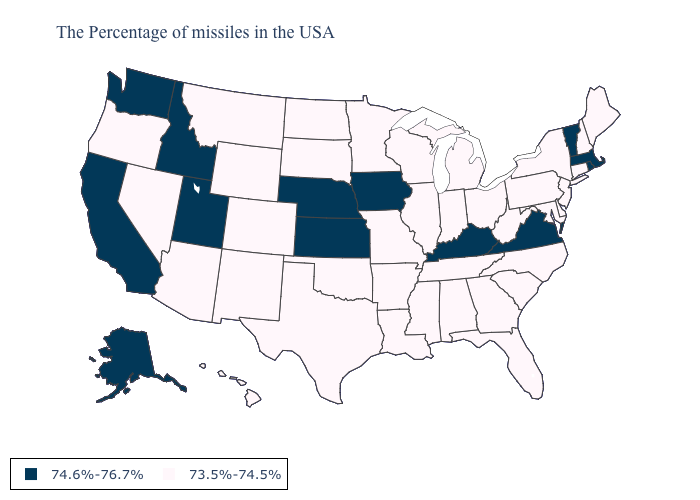Name the states that have a value in the range 74.6%-76.7%?
Be succinct. Massachusetts, Rhode Island, Vermont, Virginia, Kentucky, Iowa, Kansas, Nebraska, Utah, Idaho, California, Washington, Alaska. Name the states that have a value in the range 73.5%-74.5%?
Quick response, please. Maine, New Hampshire, Connecticut, New York, New Jersey, Delaware, Maryland, Pennsylvania, North Carolina, South Carolina, West Virginia, Ohio, Florida, Georgia, Michigan, Indiana, Alabama, Tennessee, Wisconsin, Illinois, Mississippi, Louisiana, Missouri, Arkansas, Minnesota, Oklahoma, Texas, South Dakota, North Dakota, Wyoming, Colorado, New Mexico, Montana, Arizona, Nevada, Oregon, Hawaii. What is the highest value in states that border Connecticut?
Short answer required. 74.6%-76.7%. Does the map have missing data?
Keep it brief. No. Does Hawaii have a higher value than West Virginia?
Answer briefly. No. Which states have the lowest value in the MidWest?
Answer briefly. Ohio, Michigan, Indiana, Wisconsin, Illinois, Missouri, Minnesota, South Dakota, North Dakota. What is the lowest value in the South?
Concise answer only. 73.5%-74.5%. Which states have the highest value in the USA?
Short answer required. Massachusetts, Rhode Island, Vermont, Virginia, Kentucky, Iowa, Kansas, Nebraska, Utah, Idaho, California, Washington, Alaska. What is the value of Massachusetts?
Short answer required. 74.6%-76.7%. Among the states that border Nevada , which have the lowest value?
Write a very short answer. Arizona, Oregon. Does Virginia have the lowest value in the USA?
Give a very brief answer. No. Among the states that border Nevada , does California have the lowest value?
Be succinct. No. How many symbols are there in the legend?
Concise answer only. 2. Which states hav the highest value in the West?
Answer briefly. Utah, Idaho, California, Washington, Alaska. 